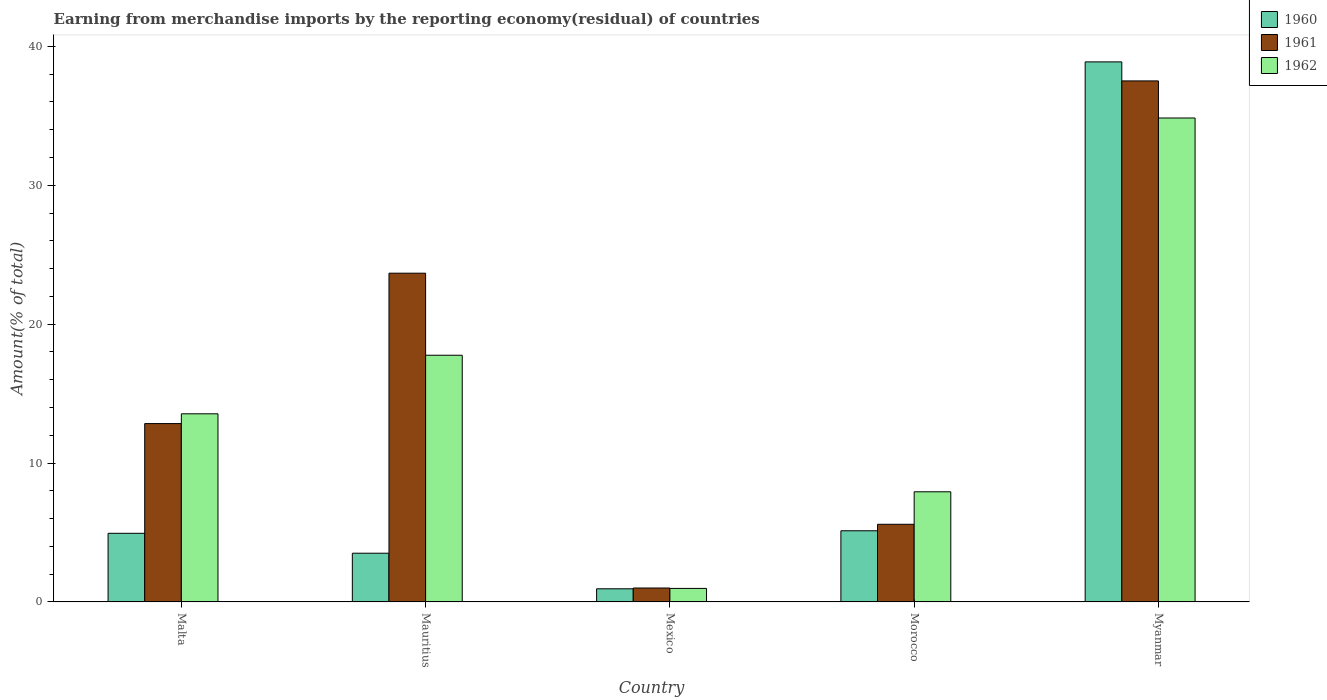How many different coloured bars are there?
Offer a very short reply. 3. How many groups of bars are there?
Give a very brief answer. 5. How many bars are there on the 2nd tick from the left?
Your response must be concise. 3. What is the label of the 5th group of bars from the left?
Keep it short and to the point. Myanmar. In how many cases, is the number of bars for a given country not equal to the number of legend labels?
Ensure brevity in your answer.  0. What is the percentage of amount earned from merchandise imports in 1962 in Mexico?
Make the answer very short. 0.97. Across all countries, what is the maximum percentage of amount earned from merchandise imports in 1960?
Your answer should be compact. 38.89. Across all countries, what is the minimum percentage of amount earned from merchandise imports in 1962?
Make the answer very short. 0.97. In which country was the percentage of amount earned from merchandise imports in 1960 maximum?
Offer a terse response. Myanmar. What is the total percentage of amount earned from merchandise imports in 1962 in the graph?
Offer a very short reply. 75.07. What is the difference between the percentage of amount earned from merchandise imports in 1961 in Mexico and that in Myanmar?
Offer a very short reply. -36.51. What is the difference between the percentage of amount earned from merchandise imports in 1962 in Myanmar and the percentage of amount earned from merchandise imports in 1961 in Mauritius?
Provide a short and direct response. 11.17. What is the average percentage of amount earned from merchandise imports in 1961 per country?
Provide a short and direct response. 16.13. What is the difference between the percentage of amount earned from merchandise imports of/in 1961 and percentage of amount earned from merchandise imports of/in 1960 in Myanmar?
Offer a terse response. -1.37. In how many countries, is the percentage of amount earned from merchandise imports in 1962 greater than 34 %?
Make the answer very short. 1. What is the ratio of the percentage of amount earned from merchandise imports in 1960 in Mauritius to that in Morocco?
Provide a short and direct response. 0.68. What is the difference between the highest and the second highest percentage of amount earned from merchandise imports in 1960?
Make the answer very short. -0.18. What is the difference between the highest and the lowest percentage of amount earned from merchandise imports in 1960?
Your response must be concise. 37.94. What does the 1st bar from the right in Myanmar represents?
Your answer should be very brief. 1962. How many bars are there?
Offer a very short reply. 15. What is the difference between two consecutive major ticks on the Y-axis?
Provide a short and direct response. 10. Does the graph contain any zero values?
Your answer should be very brief. No. Does the graph contain grids?
Provide a succinct answer. No. What is the title of the graph?
Give a very brief answer. Earning from merchandise imports by the reporting economy(residual) of countries. What is the label or title of the Y-axis?
Your answer should be very brief. Amount(% of total). What is the Amount(% of total) in 1960 in Malta?
Offer a very short reply. 4.94. What is the Amount(% of total) in 1961 in Malta?
Ensure brevity in your answer.  12.84. What is the Amount(% of total) in 1962 in Malta?
Ensure brevity in your answer.  13.55. What is the Amount(% of total) of 1960 in Mauritius?
Keep it short and to the point. 3.51. What is the Amount(% of total) in 1961 in Mauritius?
Your response must be concise. 23.67. What is the Amount(% of total) of 1962 in Mauritius?
Offer a terse response. 17.76. What is the Amount(% of total) of 1960 in Mexico?
Your answer should be compact. 0.95. What is the Amount(% of total) of 1961 in Mexico?
Ensure brevity in your answer.  1. What is the Amount(% of total) in 1962 in Mexico?
Your answer should be compact. 0.97. What is the Amount(% of total) of 1960 in Morocco?
Provide a succinct answer. 5.12. What is the Amount(% of total) of 1961 in Morocco?
Provide a succinct answer. 5.59. What is the Amount(% of total) in 1962 in Morocco?
Your answer should be very brief. 7.93. What is the Amount(% of total) in 1960 in Myanmar?
Your response must be concise. 38.89. What is the Amount(% of total) of 1961 in Myanmar?
Your answer should be compact. 37.52. What is the Amount(% of total) of 1962 in Myanmar?
Your response must be concise. 34.85. Across all countries, what is the maximum Amount(% of total) of 1960?
Ensure brevity in your answer.  38.89. Across all countries, what is the maximum Amount(% of total) of 1961?
Give a very brief answer. 37.52. Across all countries, what is the maximum Amount(% of total) in 1962?
Your response must be concise. 34.85. Across all countries, what is the minimum Amount(% of total) in 1960?
Offer a very short reply. 0.95. Across all countries, what is the minimum Amount(% of total) of 1961?
Make the answer very short. 1. Across all countries, what is the minimum Amount(% of total) of 1962?
Offer a terse response. 0.97. What is the total Amount(% of total) of 1960 in the graph?
Your answer should be compact. 53.41. What is the total Amount(% of total) of 1961 in the graph?
Ensure brevity in your answer.  80.63. What is the total Amount(% of total) in 1962 in the graph?
Provide a succinct answer. 75.07. What is the difference between the Amount(% of total) in 1960 in Malta and that in Mauritius?
Provide a succinct answer. 1.43. What is the difference between the Amount(% of total) in 1961 in Malta and that in Mauritius?
Provide a succinct answer. -10.83. What is the difference between the Amount(% of total) in 1962 in Malta and that in Mauritius?
Your answer should be compact. -4.22. What is the difference between the Amount(% of total) in 1960 in Malta and that in Mexico?
Ensure brevity in your answer.  4. What is the difference between the Amount(% of total) in 1961 in Malta and that in Mexico?
Provide a succinct answer. 11.84. What is the difference between the Amount(% of total) in 1962 in Malta and that in Mexico?
Provide a short and direct response. 12.57. What is the difference between the Amount(% of total) of 1960 in Malta and that in Morocco?
Your answer should be very brief. -0.18. What is the difference between the Amount(% of total) in 1961 in Malta and that in Morocco?
Give a very brief answer. 7.25. What is the difference between the Amount(% of total) in 1962 in Malta and that in Morocco?
Provide a short and direct response. 5.61. What is the difference between the Amount(% of total) of 1960 in Malta and that in Myanmar?
Keep it short and to the point. -33.95. What is the difference between the Amount(% of total) in 1961 in Malta and that in Myanmar?
Offer a very short reply. -24.67. What is the difference between the Amount(% of total) of 1962 in Malta and that in Myanmar?
Give a very brief answer. -21.3. What is the difference between the Amount(% of total) of 1960 in Mauritius and that in Mexico?
Your answer should be compact. 2.56. What is the difference between the Amount(% of total) in 1961 in Mauritius and that in Mexico?
Your answer should be compact. 22.67. What is the difference between the Amount(% of total) in 1962 in Mauritius and that in Mexico?
Make the answer very short. 16.79. What is the difference between the Amount(% of total) of 1960 in Mauritius and that in Morocco?
Give a very brief answer. -1.62. What is the difference between the Amount(% of total) of 1961 in Mauritius and that in Morocco?
Your answer should be compact. 18.08. What is the difference between the Amount(% of total) in 1962 in Mauritius and that in Morocco?
Your answer should be very brief. 9.83. What is the difference between the Amount(% of total) of 1960 in Mauritius and that in Myanmar?
Your response must be concise. -35.38. What is the difference between the Amount(% of total) of 1961 in Mauritius and that in Myanmar?
Provide a short and direct response. -13.85. What is the difference between the Amount(% of total) in 1962 in Mauritius and that in Myanmar?
Provide a short and direct response. -17.08. What is the difference between the Amount(% of total) of 1960 in Mexico and that in Morocco?
Keep it short and to the point. -4.18. What is the difference between the Amount(% of total) in 1961 in Mexico and that in Morocco?
Provide a succinct answer. -4.59. What is the difference between the Amount(% of total) in 1962 in Mexico and that in Morocco?
Provide a short and direct response. -6.96. What is the difference between the Amount(% of total) of 1960 in Mexico and that in Myanmar?
Provide a succinct answer. -37.94. What is the difference between the Amount(% of total) in 1961 in Mexico and that in Myanmar?
Provide a short and direct response. -36.51. What is the difference between the Amount(% of total) in 1962 in Mexico and that in Myanmar?
Provide a short and direct response. -33.87. What is the difference between the Amount(% of total) in 1960 in Morocco and that in Myanmar?
Your response must be concise. -33.76. What is the difference between the Amount(% of total) in 1961 in Morocco and that in Myanmar?
Make the answer very short. -31.93. What is the difference between the Amount(% of total) in 1962 in Morocco and that in Myanmar?
Your response must be concise. -26.91. What is the difference between the Amount(% of total) of 1960 in Malta and the Amount(% of total) of 1961 in Mauritius?
Your answer should be very brief. -18.73. What is the difference between the Amount(% of total) of 1960 in Malta and the Amount(% of total) of 1962 in Mauritius?
Your answer should be compact. -12.82. What is the difference between the Amount(% of total) of 1961 in Malta and the Amount(% of total) of 1962 in Mauritius?
Provide a succinct answer. -4.92. What is the difference between the Amount(% of total) in 1960 in Malta and the Amount(% of total) in 1961 in Mexico?
Your response must be concise. 3.94. What is the difference between the Amount(% of total) in 1960 in Malta and the Amount(% of total) in 1962 in Mexico?
Provide a short and direct response. 3.97. What is the difference between the Amount(% of total) of 1961 in Malta and the Amount(% of total) of 1962 in Mexico?
Provide a succinct answer. 11.87. What is the difference between the Amount(% of total) of 1960 in Malta and the Amount(% of total) of 1961 in Morocco?
Your answer should be very brief. -0.65. What is the difference between the Amount(% of total) in 1960 in Malta and the Amount(% of total) in 1962 in Morocco?
Your answer should be compact. -2.99. What is the difference between the Amount(% of total) of 1961 in Malta and the Amount(% of total) of 1962 in Morocco?
Ensure brevity in your answer.  4.91. What is the difference between the Amount(% of total) of 1960 in Malta and the Amount(% of total) of 1961 in Myanmar?
Your answer should be very brief. -32.58. What is the difference between the Amount(% of total) of 1960 in Malta and the Amount(% of total) of 1962 in Myanmar?
Offer a terse response. -29.9. What is the difference between the Amount(% of total) in 1961 in Malta and the Amount(% of total) in 1962 in Myanmar?
Ensure brevity in your answer.  -22. What is the difference between the Amount(% of total) of 1960 in Mauritius and the Amount(% of total) of 1961 in Mexico?
Your answer should be compact. 2.51. What is the difference between the Amount(% of total) in 1960 in Mauritius and the Amount(% of total) in 1962 in Mexico?
Your answer should be compact. 2.53. What is the difference between the Amount(% of total) in 1961 in Mauritius and the Amount(% of total) in 1962 in Mexico?
Your answer should be very brief. 22.7. What is the difference between the Amount(% of total) of 1960 in Mauritius and the Amount(% of total) of 1961 in Morocco?
Your response must be concise. -2.08. What is the difference between the Amount(% of total) of 1960 in Mauritius and the Amount(% of total) of 1962 in Morocco?
Your answer should be very brief. -4.42. What is the difference between the Amount(% of total) in 1961 in Mauritius and the Amount(% of total) in 1962 in Morocco?
Provide a short and direct response. 15.74. What is the difference between the Amount(% of total) in 1960 in Mauritius and the Amount(% of total) in 1961 in Myanmar?
Ensure brevity in your answer.  -34.01. What is the difference between the Amount(% of total) of 1960 in Mauritius and the Amount(% of total) of 1962 in Myanmar?
Offer a very short reply. -31.34. What is the difference between the Amount(% of total) in 1961 in Mauritius and the Amount(% of total) in 1962 in Myanmar?
Your answer should be very brief. -11.17. What is the difference between the Amount(% of total) of 1960 in Mexico and the Amount(% of total) of 1961 in Morocco?
Offer a terse response. -4.65. What is the difference between the Amount(% of total) in 1960 in Mexico and the Amount(% of total) in 1962 in Morocco?
Provide a short and direct response. -6.99. What is the difference between the Amount(% of total) in 1961 in Mexico and the Amount(% of total) in 1962 in Morocco?
Keep it short and to the point. -6.93. What is the difference between the Amount(% of total) in 1960 in Mexico and the Amount(% of total) in 1961 in Myanmar?
Keep it short and to the point. -36.57. What is the difference between the Amount(% of total) in 1960 in Mexico and the Amount(% of total) in 1962 in Myanmar?
Offer a very short reply. -33.9. What is the difference between the Amount(% of total) in 1961 in Mexico and the Amount(% of total) in 1962 in Myanmar?
Offer a terse response. -33.84. What is the difference between the Amount(% of total) of 1960 in Morocco and the Amount(% of total) of 1961 in Myanmar?
Your answer should be very brief. -32.39. What is the difference between the Amount(% of total) of 1960 in Morocco and the Amount(% of total) of 1962 in Myanmar?
Keep it short and to the point. -29.72. What is the difference between the Amount(% of total) in 1961 in Morocco and the Amount(% of total) in 1962 in Myanmar?
Your answer should be very brief. -29.26. What is the average Amount(% of total) of 1960 per country?
Keep it short and to the point. 10.68. What is the average Amount(% of total) of 1961 per country?
Provide a succinct answer. 16.13. What is the average Amount(% of total) of 1962 per country?
Your answer should be very brief. 15.01. What is the difference between the Amount(% of total) of 1960 and Amount(% of total) of 1961 in Malta?
Provide a short and direct response. -7.9. What is the difference between the Amount(% of total) of 1960 and Amount(% of total) of 1962 in Malta?
Offer a terse response. -8.6. What is the difference between the Amount(% of total) in 1961 and Amount(% of total) in 1962 in Malta?
Offer a terse response. -0.7. What is the difference between the Amount(% of total) in 1960 and Amount(% of total) in 1961 in Mauritius?
Give a very brief answer. -20.16. What is the difference between the Amount(% of total) in 1960 and Amount(% of total) in 1962 in Mauritius?
Give a very brief answer. -14.26. What is the difference between the Amount(% of total) of 1961 and Amount(% of total) of 1962 in Mauritius?
Provide a succinct answer. 5.91. What is the difference between the Amount(% of total) of 1960 and Amount(% of total) of 1961 in Mexico?
Your response must be concise. -0.06. What is the difference between the Amount(% of total) in 1960 and Amount(% of total) in 1962 in Mexico?
Give a very brief answer. -0.03. What is the difference between the Amount(% of total) in 1961 and Amount(% of total) in 1962 in Mexico?
Ensure brevity in your answer.  0.03. What is the difference between the Amount(% of total) of 1960 and Amount(% of total) of 1961 in Morocco?
Give a very brief answer. -0.47. What is the difference between the Amount(% of total) of 1960 and Amount(% of total) of 1962 in Morocco?
Your answer should be compact. -2.81. What is the difference between the Amount(% of total) in 1961 and Amount(% of total) in 1962 in Morocco?
Keep it short and to the point. -2.34. What is the difference between the Amount(% of total) in 1960 and Amount(% of total) in 1961 in Myanmar?
Give a very brief answer. 1.37. What is the difference between the Amount(% of total) of 1960 and Amount(% of total) of 1962 in Myanmar?
Your response must be concise. 4.04. What is the difference between the Amount(% of total) of 1961 and Amount(% of total) of 1962 in Myanmar?
Your answer should be very brief. 2.67. What is the ratio of the Amount(% of total) in 1960 in Malta to that in Mauritius?
Offer a very short reply. 1.41. What is the ratio of the Amount(% of total) in 1961 in Malta to that in Mauritius?
Your answer should be compact. 0.54. What is the ratio of the Amount(% of total) of 1962 in Malta to that in Mauritius?
Your answer should be very brief. 0.76. What is the ratio of the Amount(% of total) of 1960 in Malta to that in Mexico?
Ensure brevity in your answer.  5.22. What is the ratio of the Amount(% of total) of 1961 in Malta to that in Mexico?
Keep it short and to the point. 12.8. What is the ratio of the Amount(% of total) of 1962 in Malta to that in Mexico?
Provide a succinct answer. 13.9. What is the ratio of the Amount(% of total) in 1960 in Malta to that in Morocco?
Your answer should be compact. 0.96. What is the ratio of the Amount(% of total) in 1961 in Malta to that in Morocco?
Provide a succinct answer. 2.3. What is the ratio of the Amount(% of total) in 1962 in Malta to that in Morocco?
Your response must be concise. 1.71. What is the ratio of the Amount(% of total) of 1960 in Malta to that in Myanmar?
Your response must be concise. 0.13. What is the ratio of the Amount(% of total) in 1961 in Malta to that in Myanmar?
Your answer should be very brief. 0.34. What is the ratio of the Amount(% of total) of 1962 in Malta to that in Myanmar?
Keep it short and to the point. 0.39. What is the ratio of the Amount(% of total) in 1960 in Mauritius to that in Mexico?
Your answer should be very brief. 3.71. What is the ratio of the Amount(% of total) of 1961 in Mauritius to that in Mexico?
Keep it short and to the point. 23.59. What is the ratio of the Amount(% of total) of 1962 in Mauritius to that in Mexico?
Make the answer very short. 18.23. What is the ratio of the Amount(% of total) of 1960 in Mauritius to that in Morocco?
Provide a succinct answer. 0.68. What is the ratio of the Amount(% of total) in 1961 in Mauritius to that in Morocco?
Offer a terse response. 4.23. What is the ratio of the Amount(% of total) in 1962 in Mauritius to that in Morocco?
Ensure brevity in your answer.  2.24. What is the ratio of the Amount(% of total) in 1960 in Mauritius to that in Myanmar?
Your response must be concise. 0.09. What is the ratio of the Amount(% of total) in 1961 in Mauritius to that in Myanmar?
Ensure brevity in your answer.  0.63. What is the ratio of the Amount(% of total) in 1962 in Mauritius to that in Myanmar?
Make the answer very short. 0.51. What is the ratio of the Amount(% of total) of 1960 in Mexico to that in Morocco?
Your response must be concise. 0.18. What is the ratio of the Amount(% of total) of 1961 in Mexico to that in Morocco?
Ensure brevity in your answer.  0.18. What is the ratio of the Amount(% of total) in 1962 in Mexico to that in Morocco?
Offer a terse response. 0.12. What is the ratio of the Amount(% of total) in 1960 in Mexico to that in Myanmar?
Offer a terse response. 0.02. What is the ratio of the Amount(% of total) in 1961 in Mexico to that in Myanmar?
Your answer should be compact. 0.03. What is the ratio of the Amount(% of total) in 1962 in Mexico to that in Myanmar?
Make the answer very short. 0.03. What is the ratio of the Amount(% of total) of 1960 in Morocco to that in Myanmar?
Give a very brief answer. 0.13. What is the ratio of the Amount(% of total) in 1961 in Morocco to that in Myanmar?
Your response must be concise. 0.15. What is the ratio of the Amount(% of total) of 1962 in Morocco to that in Myanmar?
Provide a short and direct response. 0.23. What is the difference between the highest and the second highest Amount(% of total) in 1960?
Your answer should be very brief. 33.76. What is the difference between the highest and the second highest Amount(% of total) in 1961?
Your answer should be compact. 13.85. What is the difference between the highest and the second highest Amount(% of total) of 1962?
Your answer should be compact. 17.08. What is the difference between the highest and the lowest Amount(% of total) of 1960?
Offer a very short reply. 37.94. What is the difference between the highest and the lowest Amount(% of total) of 1961?
Offer a terse response. 36.51. What is the difference between the highest and the lowest Amount(% of total) in 1962?
Make the answer very short. 33.87. 